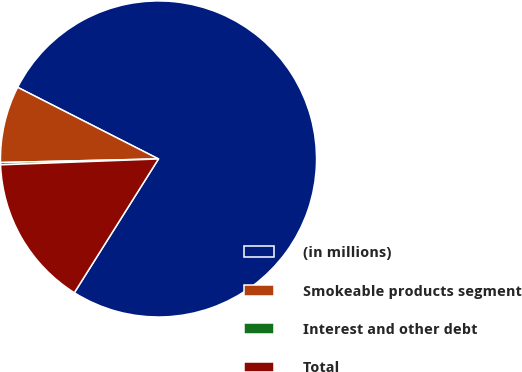Convert chart. <chart><loc_0><loc_0><loc_500><loc_500><pie_chart><fcel>(in millions)<fcel>Smokeable products segment<fcel>Interest and other debt<fcel>Total<nl><fcel>76.45%<fcel>7.85%<fcel>0.23%<fcel>15.47%<nl></chart> 